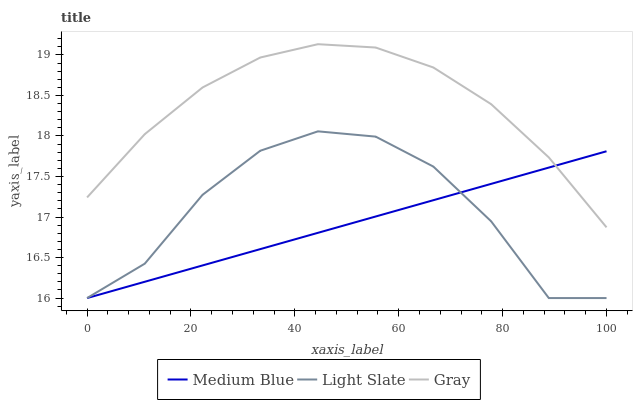Does Gray have the minimum area under the curve?
Answer yes or no. No. Does Medium Blue have the maximum area under the curve?
Answer yes or no. No. Is Gray the smoothest?
Answer yes or no. No. Is Gray the roughest?
Answer yes or no. No. Does Gray have the lowest value?
Answer yes or no. No. Does Medium Blue have the highest value?
Answer yes or no. No. Is Light Slate less than Gray?
Answer yes or no. Yes. Is Gray greater than Light Slate?
Answer yes or no. Yes. Does Light Slate intersect Gray?
Answer yes or no. No. 